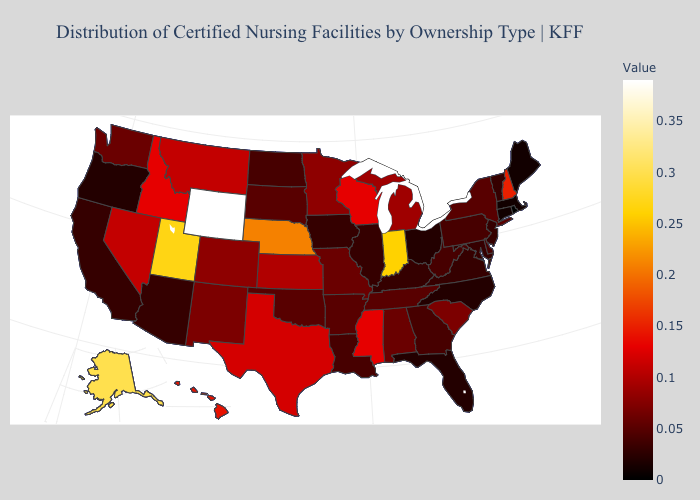Which states have the highest value in the USA?
Give a very brief answer. Wyoming. Is the legend a continuous bar?
Answer briefly. Yes. Does Massachusetts have a lower value than Mississippi?
Answer briefly. Yes. Which states hav the highest value in the Northeast?
Be succinct. New Hampshire. Is the legend a continuous bar?
Be succinct. Yes. 